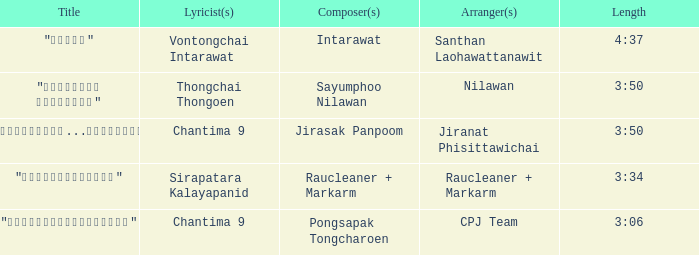Who was the composer of "ขอโทษ"? Intarawat. 